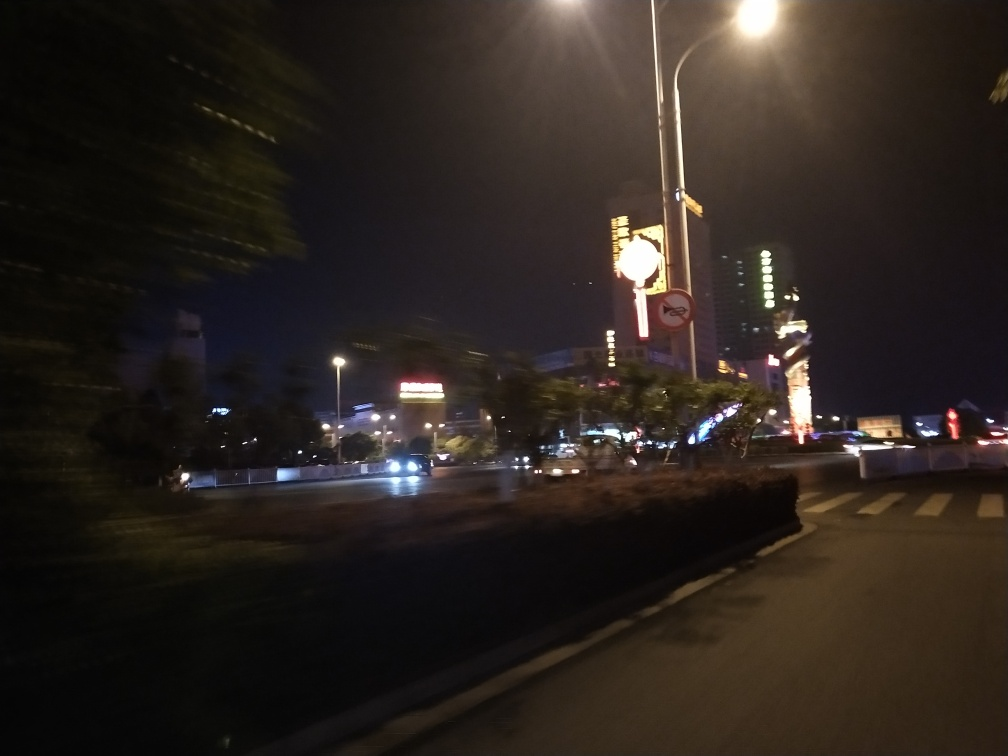Are there any landmarks or features that hint at the location where this photo was taken? While the image is blurry, we can observe neon signage and modern buildings with unique architectural designs, which might be suggestive of a busy, commercial district within a city. The precise location cannot be determined from this image alone, as these features are common in many urban areas around the world. 